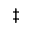Convert formula to latex. <formula><loc_0><loc_0><loc_500><loc_500>\ddag</formula> 